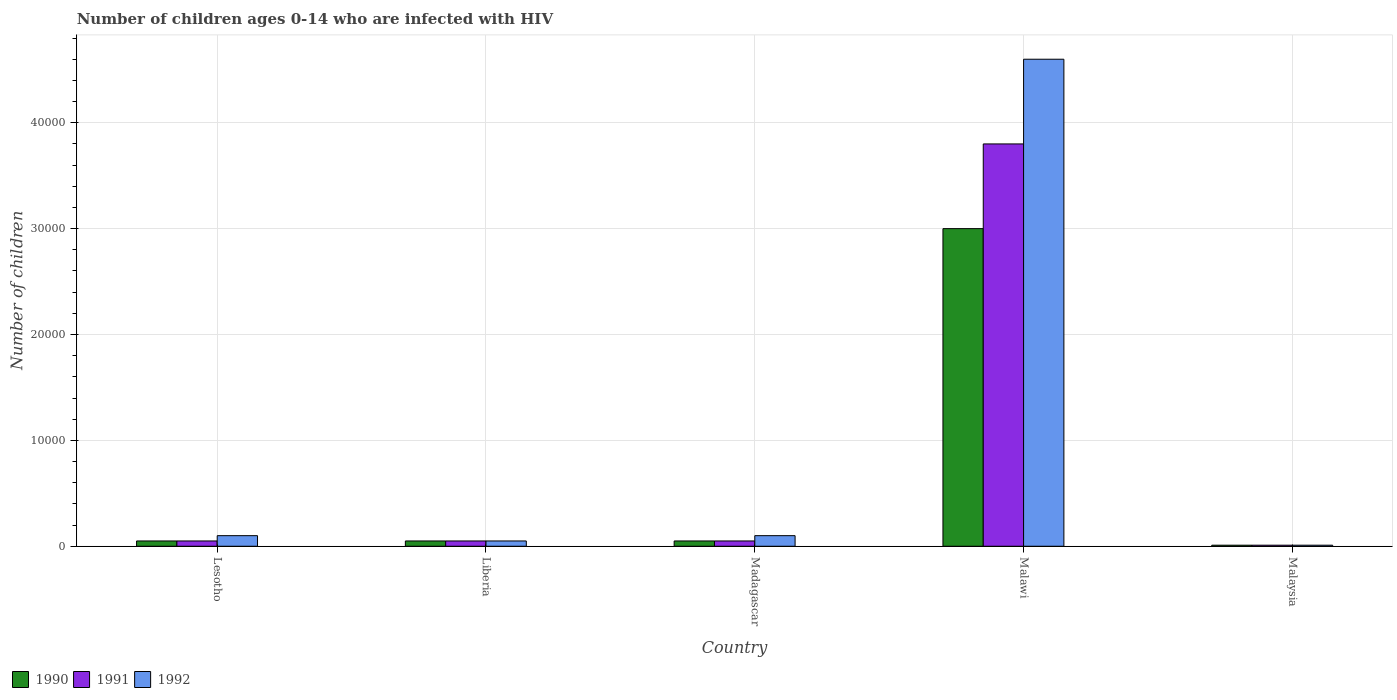How many different coloured bars are there?
Provide a succinct answer. 3. How many groups of bars are there?
Provide a succinct answer. 5. Are the number of bars on each tick of the X-axis equal?
Provide a succinct answer. Yes. How many bars are there on the 4th tick from the left?
Keep it short and to the point. 3. How many bars are there on the 1st tick from the right?
Make the answer very short. 3. What is the label of the 1st group of bars from the left?
Ensure brevity in your answer.  Lesotho. What is the number of HIV infected children in 1992 in Liberia?
Make the answer very short. 500. Across all countries, what is the maximum number of HIV infected children in 1991?
Your response must be concise. 3.80e+04. Across all countries, what is the minimum number of HIV infected children in 1990?
Keep it short and to the point. 100. In which country was the number of HIV infected children in 1992 maximum?
Offer a terse response. Malawi. In which country was the number of HIV infected children in 1990 minimum?
Provide a short and direct response. Malaysia. What is the total number of HIV infected children in 1990 in the graph?
Make the answer very short. 3.16e+04. What is the difference between the number of HIV infected children in 1990 in Lesotho and that in Malawi?
Ensure brevity in your answer.  -2.95e+04. What is the difference between the number of HIV infected children in 1990 in Malawi and the number of HIV infected children in 1992 in Lesotho?
Offer a terse response. 2.90e+04. What is the average number of HIV infected children in 1991 per country?
Provide a succinct answer. 7920. In how many countries, is the number of HIV infected children in 1990 greater than 14000?
Your answer should be compact. 1. What is the ratio of the number of HIV infected children in 1991 in Liberia to that in Malawi?
Ensure brevity in your answer.  0.01. Is the number of HIV infected children in 1992 in Madagascar less than that in Malaysia?
Provide a short and direct response. No. What is the difference between the highest and the second highest number of HIV infected children in 1991?
Offer a terse response. 3.75e+04. What is the difference between the highest and the lowest number of HIV infected children in 1990?
Your answer should be compact. 2.99e+04. In how many countries, is the number of HIV infected children in 1992 greater than the average number of HIV infected children in 1992 taken over all countries?
Provide a short and direct response. 1. Is the sum of the number of HIV infected children in 1992 in Lesotho and Madagascar greater than the maximum number of HIV infected children in 1991 across all countries?
Make the answer very short. No. What does the 2nd bar from the left in Malawi represents?
Your answer should be compact. 1991. How many bars are there?
Offer a terse response. 15. How many countries are there in the graph?
Provide a succinct answer. 5. Where does the legend appear in the graph?
Provide a short and direct response. Bottom left. How many legend labels are there?
Keep it short and to the point. 3. What is the title of the graph?
Your response must be concise. Number of children ages 0-14 who are infected with HIV. Does "1963" appear as one of the legend labels in the graph?
Your response must be concise. No. What is the label or title of the X-axis?
Provide a short and direct response. Country. What is the label or title of the Y-axis?
Ensure brevity in your answer.  Number of children. What is the Number of children of 1992 in Lesotho?
Make the answer very short. 1000. What is the Number of children of 1991 in Malawi?
Offer a terse response. 3.80e+04. What is the Number of children of 1992 in Malawi?
Provide a short and direct response. 4.60e+04. What is the Number of children of 1990 in Malaysia?
Provide a succinct answer. 100. What is the Number of children of 1991 in Malaysia?
Offer a terse response. 100. What is the Number of children of 1992 in Malaysia?
Offer a terse response. 100. Across all countries, what is the maximum Number of children of 1990?
Provide a succinct answer. 3.00e+04. Across all countries, what is the maximum Number of children of 1991?
Keep it short and to the point. 3.80e+04. Across all countries, what is the maximum Number of children of 1992?
Ensure brevity in your answer.  4.60e+04. What is the total Number of children of 1990 in the graph?
Keep it short and to the point. 3.16e+04. What is the total Number of children of 1991 in the graph?
Provide a short and direct response. 3.96e+04. What is the total Number of children in 1992 in the graph?
Ensure brevity in your answer.  4.86e+04. What is the difference between the Number of children in 1990 in Lesotho and that in Liberia?
Make the answer very short. 0. What is the difference between the Number of children of 1991 in Lesotho and that in Liberia?
Keep it short and to the point. 0. What is the difference between the Number of children in 1990 in Lesotho and that in Madagascar?
Your answer should be compact. 0. What is the difference between the Number of children of 1991 in Lesotho and that in Madagascar?
Keep it short and to the point. 0. What is the difference between the Number of children of 1990 in Lesotho and that in Malawi?
Your response must be concise. -2.95e+04. What is the difference between the Number of children in 1991 in Lesotho and that in Malawi?
Make the answer very short. -3.75e+04. What is the difference between the Number of children in 1992 in Lesotho and that in Malawi?
Ensure brevity in your answer.  -4.50e+04. What is the difference between the Number of children of 1990 in Lesotho and that in Malaysia?
Ensure brevity in your answer.  400. What is the difference between the Number of children of 1991 in Lesotho and that in Malaysia?
Make the answer very short. 400. What is the difference between the Number of children of 1992 in Lesotho and that in Malaysia?
Your answer should be compact. 900. What is the difference between the Number of children of 1990 in Liberia and that in Madagascar?
Your answer should be compact. 0. What is the difference between the Number of children of 1992 in Liberia and that in Madagascar?
Keep it short and to the point. -500. What is the difference between the Number of children of 1990 in Liberia and that in Malawi?
Your answer should be very brief. -2.95e+04. What is the difference between the Number of children of 1991 in Liberia and that in Malawi?
Provide a succinct answer. -3.75e+04. What is the difference between the Number of children of 1992 in Liberia and that in Malawi?
Ensure brevity in your answer.  -4.55e+04. What is the difference between the Number of children of 1991 in Liberia and that in Malaysia?
Ensure brevity in your answer.  400. What is the difference between the Number of children in 1990 in Madagascar and that in Malawi?
Keep it short and to the point. -2.95e+04. What is the difference between the Number of children of 1991 in Madagascar and that in Malawi?
Your response must be concise. -3.75e+04. What is the difference between the Number of children in 1992 in Madagascar and that in Malawi?
Make the answer very short. -4.50e+04. What is the difference between the Number of children in 1992 in Madagascar and that in Malaysia?
Your response must be concise. 900. What is the difference between the Number of children in 1990 in Malawi and that in Malaysia?
Offer a very short reply. 2.99e+04. What is the difference between the Number of children in 1991 in Malawi and that in Malaysia?
Give a very brief answer. 3.79e+04. What is the difference between the Number of children of 1992 in Malawi and that in Malaysia?
Your response must be concise. 4.59e+04. What is the difference between the Number of children of 1990 in Lesotho and the Number of children of 1991 in Liberia?
Offer a very short reply. 0. What is the difference between the Number of children of 1991 in Lesotho and the Number of children of 1992 in Liberia?
Your response must be concise. 0. What is the difference between the Number of children in 1990 in Lesotho and the Number of children in 1991 in Madagascar?
Your answer should be very brief. 0. What is the difference between the Number of children of 1990 in Lesotho and the Number of children of 1992 in Madagascar?
Keep it short and to the point. -500. What is the difference between the Number of children of 1991 in Lesotho and the Number of children of 1992 in Madagascar?
Your response must be concise. -500. What is the difference between the Number of children of 1990 in Lesotho and the Number of children of 1991 in Malawi?
Give a very brief answer. -3.75e+04. What is the difference between the Number of children of 1990 in Lesotho and the Number of children of 1992 in Malawi?
Your answer should be compact. -4.55e+04. What is the difference between the Number of children of 1991 in Lesotho and the Number of children of 1992 in Malawi?
Offer a terse response. -4.55e+04. What is the difference between the Number of children of 1990 in Lesotho and the Number of children of 1991 in Malaysia?
Offer a terse response. 400. What is the difference between the Number of children of 1990 in Liberia and the Number of children of 1991 in Madagascar?
Offer a terse response. 0. What is the difference between the Number of children in 1990 in Liberia and the Number of children in 1992 in Madagascar?
Your answer should be very brief. -500. What is the difference between the Number of children in 1991 in Liberia and the Number of children in 1992 in Madagascar?
Your answer should be compact. -500. What is the difference between the Number of children in 1990 in Liberia and the Number of children in 1991 in Malawi?
Make the answer very short. -3.75e+04. What is the difference between the Number of children in 1990 in Liberia and the Number of children in 1992 in Malawi?
Offer a terse response. -4.55e+04. What is the difference between the Number of children in 1991 in Liberia and the Number of children in 1992 in Malawi?
Offer a terse response. -4.55e+04. What is the difference between the Number of children of 1990 in Liberia and the Number of children of 1991 in Malaysia?
Your response must be concise. 400. What is the difference between the Number of children of 1991 in Liberia and the Number of children of 1992 in Malaysia?
Offer a terse response. 400. What is the difference between the Number of children in 1990 in Madagascar and the Number of children in 1991 in Malawi?
Keep it short and to the point. -3.75e+04. What is the difference between the Number of children of 1990 in Madagascar and the Number of children of 1992 in Malawi?
Keep it short and to the point. -4.55e+04. What is the difference between the Number of children of 1991 in Madagascar and the Number of children of 1992 in Malawi?
Ensure brevity in your answer.  -4.55e+04. What is the difference between the Number of children in 1990 in Madagascar and the Number of children in 1991 in Malaysia?
Keep it short and to the point. 400. What is the difference between the Number of children in 1990 in Malawi and the Number of children in 1991 in Malaysia?
Offer a very short reply. 2.99e+04. What is the difference between the Number of children in 1990 in Malawi and the Number of children in 1992 in Malaysia?
Keep it short and to the point. 2.99e+04. What is the difference between the Number of children of 1991 in Malawi and the Number of children of 1992 in Malaysia?
Provide a succinct answer. 3.79e+04. What is the average Number of children in 1990 per country?
Give a very brief answer. 6320. What is the average Number of children of 1991 per country?
Keep it short and to the point. 7920. What is the average Number of children in 1992 per country?
Provide a short and direct response. 9720. What is the difference between the Number of children in 1990 and Number of children in 1991 in Lesotho?
Offer a very short reply. 0. What is the difference between the Number of children of 1990 and Number of children of 1992 in Lesotho?
Offer a terse response. -500. What is the difference between the Number of children of 1991 and Number of children of 1992 in Lesotho?
Give a very brief answer. -500. What is the difference between the Number of children of 1990 and Number of children of 1991 in Liberia?
Your answer should be compact. 0. What is the difference between the Number of children in 1990 and Number of children in 1992 in Liberia?
Your answer should be compact. 0. What is the difference between the Number of children of 1990 and Number of children of 1992 in Madagascar?
Make the answer very short. -500. What is the difference between the Number of children of 1991 and Number of children of 1992 in Madagascar?
Offer a terse response. -500. What is the difference between the Number of children in 1990 and Number of children in 1991 in Malawi?
Offer a terse response. -8000. What is the difference between the Number of children of 1990 and Number of children of 1992 in Malawi?
Your response must be concise. -1.60e+04. What is the difference between the Number of children in 1991 and Number of children in 1992 in Malawi?
Your response must be concise. -8000. What is the difference between the Number of children in 1990 and Number of children in 1991 in Malaysia?
Offer a very short reply. 0. What is the difference between the Number of children in 1990 and Number of children in 1992 in Malaysia?
Your answer should be very brief. 0. What is the ratio of the Number of children in 1990 in Lesotho to that in Liberia?
Your answer should be very brief. 1. What is the ratio of the Number of children of 1991 in Lesotho to that in Liberia?
Provide a succinct answer. 1. What is the ratio of the Number of children of 1992 in Lesotho to that in Liberia?
Offer a terse response. 2. What is the ratio of the Number of children of 1991 in Lesotho to that in Madagascar?
Your answer should be very brief. 1. What is the ratio of the Number of children of 1992 in Lesotho to that in Madagascar?
Keep it short and to the point. 1. What is the ratio of the Number of children in 1990 in Lesotho to that in Malawi?
Your response must be concise. 0.02. What is the ratio of the Number of children of 1991 in Lesotho to that in Malawi?
Your response must be concise. 0.01. What is the ratio of the Number of children of 1992 in Lesotho to that in Malawi?
Your response must be concise. 0.02. What is the ratio of the Number of children in 1990 in Lesotho to that in Malaysia?
Offer a terse response. 5. What is the ratio of the Number of children of 1991 in Liberia to that in Madagascar?
Your answer should be very brief. 1. What is the ratio of the Number of children in 1990 in Liberia to that in Malawi?
Make the answer very short. 0.02. What is the ratio of the Number of children in 1991 in Liberia to that in Malawi?
Ensure brevity in your answer.  0.01. What is the ratio of the Number of children in 1992 in Liberia to that in Malawi?
Offer a very short reply. 0.01. What is the ratio of the Number of children in 1990 in Liberia to that in Malaysia?
Your answer should be very brief. 5. What is the ratio of the Number of children of 1991 in Liberia to that in Malaysia?
Your answer should be compact. 5. What is the ratio of the Number of children in 1992 in Liberia to that in Malaysia?
Make the answer very short. 5. What is the ratio of the Number of children in 1990 in Madagascar to that in Malawi?
Make the answer very short. 0.02. What is the ratio of the Number of children of 1991 in Madagascar to that in Malawi?
Provide a short and direct response. 0.01. What is the ratio of the Number of children of 1992 in Madagascar to that in Malawi?
Offer a terse response. 0.02. What is the ratio of the Number of children of 1990 in Madagascar to that in Malaysia?
Give a very brief answer. 5. What is the ratio of the Number of children in 1990 in Malawi to that in Malaysia?
Provide a succinct answer. 300. What is the ratio of the Number of children of 1991 in Malawi to that in Malaysia?
Provide a succinct answer. 380. What is the ratio of the Number of children in 1992 in Malawi to that in Malaysia?
Provide a succinct answer. 460. What is the difference between the highest and the second highest Number of children in 1990?
Your answer should be compact. 2.95e+04. What is the difference between the highest and the second highest Number of children in 1991?
Offer a very short reply. 3.75e+04. What is the difference between the highest and the second highest Number of children in 1992?
Provide a succinct answer. 4.50e+04. What is the difference between the highest and the lowest Number of children in 1990?
Ensure brevity in your answer.  2.99e+04. What is the difference between the highest and the lowest Number of children of 1991?
Your response must be concise. 3.79e+04. What is the difference between the highest and the lowest Number of children in 1992?
Ensure brevity in your answer.  4.59e+04. 